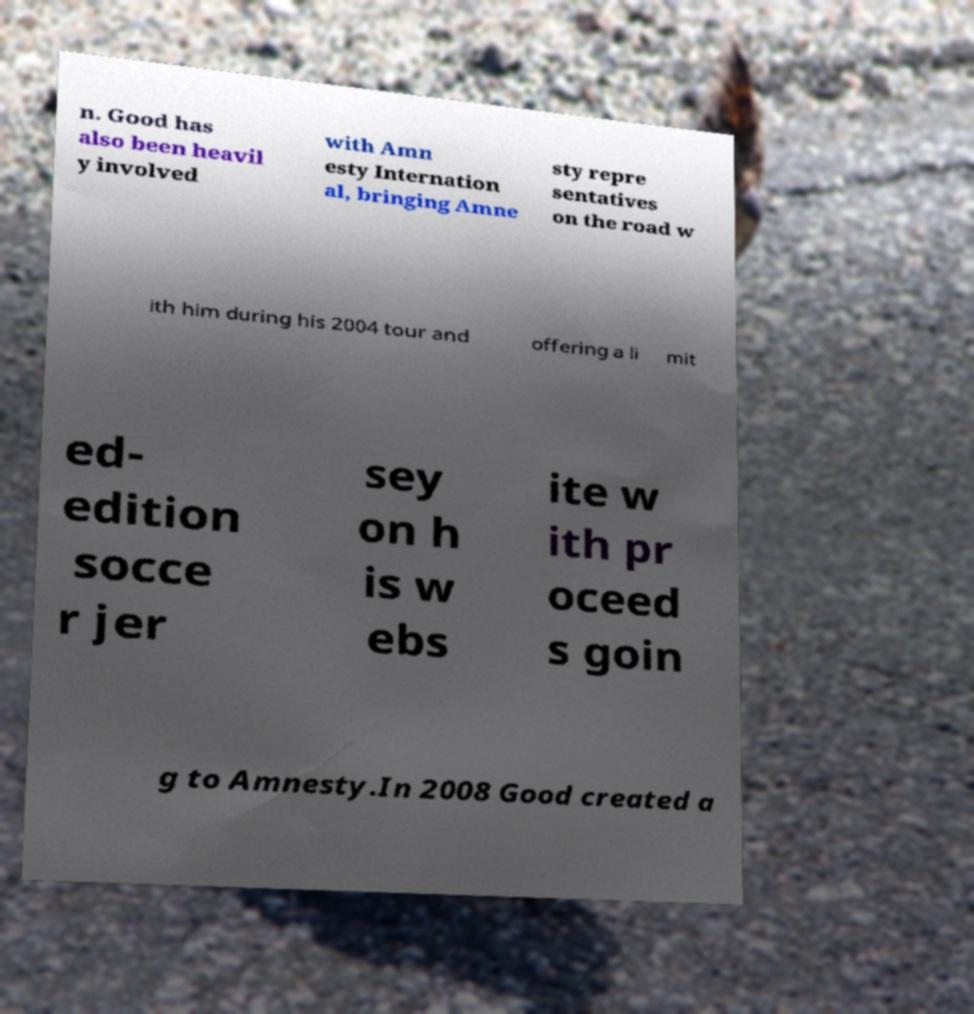Can you accurately transcribe the text from the provided image for me? n. Good has also been heavil y involved with Amn esty Internation al, bringing Amne sty repre sentatives on the road w ith him during his 2004 tour and offering a li mit ed- edition socce r jer sey on h is w ebs ite w ith pr oceed s goin g to Amnesty.In 2008 Good created a 